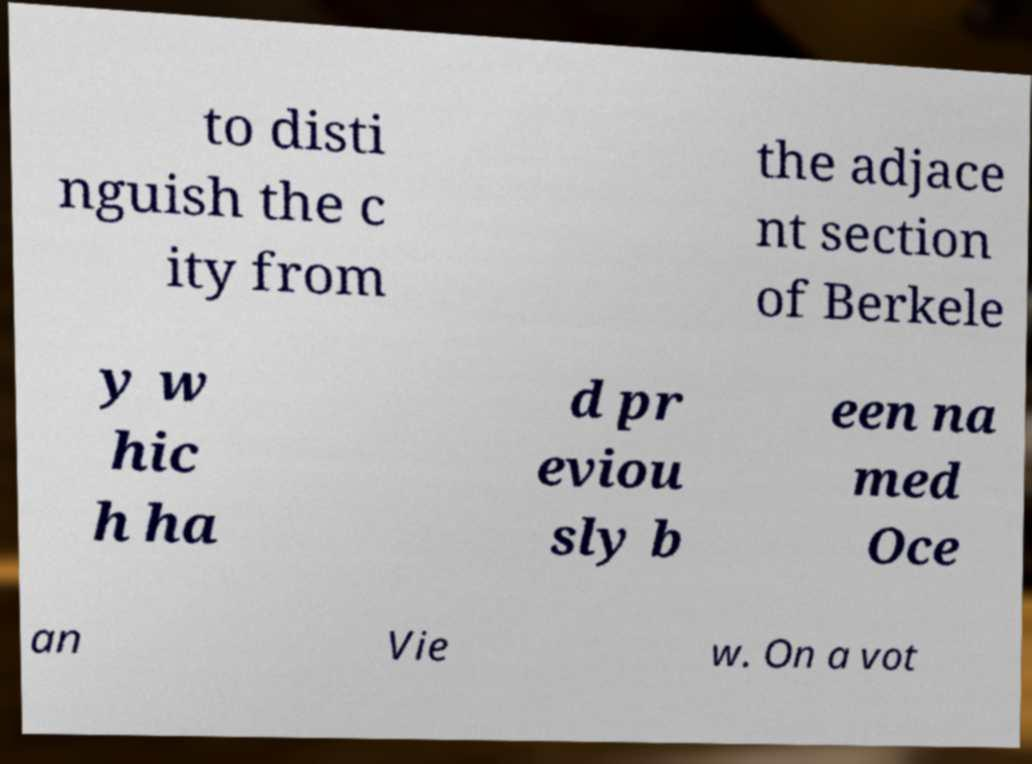Could you extract and type out the text from this image? to disti nguish the c ity from the adjace nt section of Berkele y w hic h ha d pr eviou sly b een na med Oce an Vie w. On a vot 